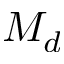Convert formula to latex. <formula><loc_0><loc_0><loc_500><loc_500>M _ { d }</formula> 